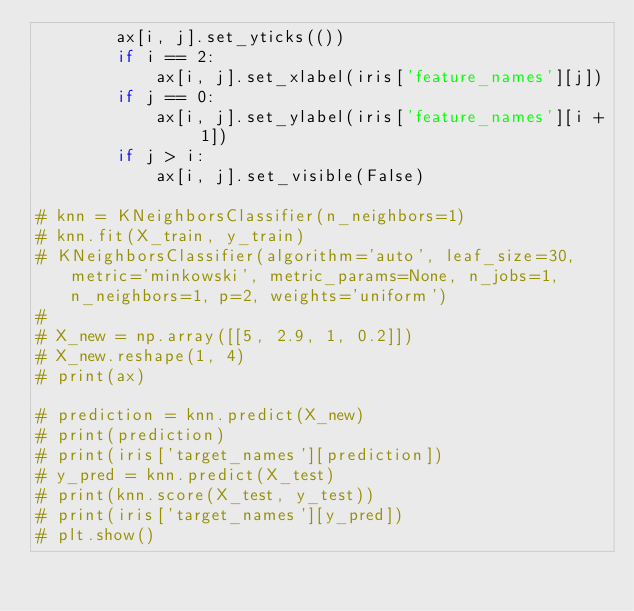<code> <loc_0><loc_0><loc_500><loc_500><_Python_>        ax[i, j].set_yticks(())
        if i == 2:
            ax[i, j].set_xlabel(iris['feature_names'][j])
        if j == 0:
            ax[i, j].set_ylabel(iris['feature_names'][i + 1])
        if j > i:
            ax[i, j].set_visible(False)

# knn = KNeighborsClassifier(n_neighbors=1)
# knn.fit(X_train, y_train)
# KNeighborsClassifier(algorithm='auto', leaf_size=30, metric='minkowski', metric_params=None, n_jobs=1, n_neighbors=1, p=2, weights='uniform')
#
# X_new = np.array([[5, 2.9, 1, 0.2]])
# X_new.reshape(1, 4)
# print(ax)

# prediction = knn.predict(X_new)
# print(prediction)
# print(iris['target_names'][prediction])
# y_pred = knn.predict(X_test)
# print(knn.score(X_test, y_test))
# print(iris['target_names'][y_pred])
# plt.show()


</code> 